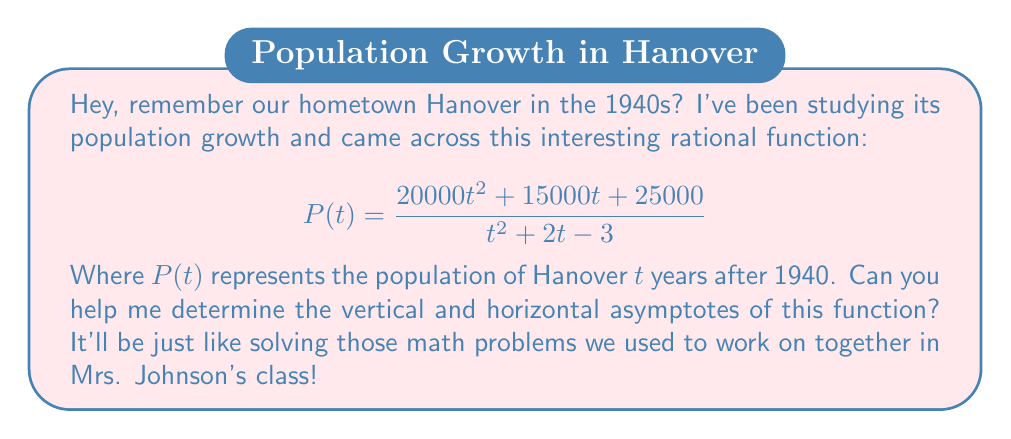What is the answer to this math problem? Let's approach this step-by-step, just like we learned back in school:

1) For vertical asymptotes, we need to find where the denominator equals zero:
   $$t^2 + 2t - 3 = 0$$
   $$(t+3)(t-1) = 0$$
   So, $t = -3$ or $t = 1$

   However, $t = -3$ doesn't make sense in our context as we're starting from 1940, so we only consider $t = 1$ as a vertical asymptote.

2) For the horizontal asymptote, we compare the degrees of the numerator and denominator:
   - Numerator degree: 2
   - Denominator degree: 2

   When these are equal, the horizontal asymptote is the ratio of the leading coefficients:

   $$\lim_{t \to \infty} P(t) = \frac{20000}{1} = 20000$$

3) To verify, let's calculate the limits as $t$ approaches our asymptotes:

   As $t \to 1$:
   $$\lim_{t \to 1} P(t) = \frac{20000(1)^2 + 15000(1) + 25000}{(1)^2 + 2(1) - 3} = \frac{60000}{0} = \text{undefined}$$

   As $t \to \infty$:
   $$\lim_{t \to \infty} P(t) = \lim_{t \to \infty} \frac{20000t^2 + 15000t + 25000}{t^2 + 2t - 3} = 20000$$

Therefore, we have confirmed our asymptotes.
Answer: Vertical asymptote: $t = 1$; Horizontal asymptote: $P(t) = 20000$ 